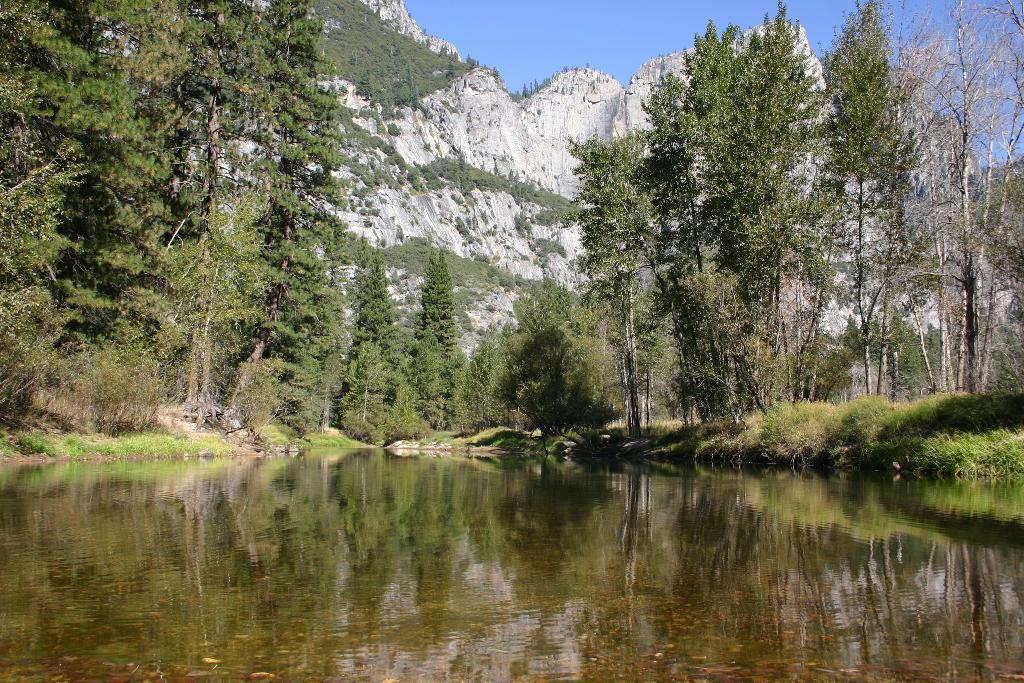What can be seen at the top of the image? The sky is visible towards the top of the image. What type of natural landforms are present in the image? There are mountains in the image. What type of vegetation can be seen in the image? There are trees and grass in the image. What is visible towards the bottom of the image? There is water visible towards the bottom of the image. What type of breakfast is being served on the vessel in the image? There is no vessel or breakfast present in the image; it features natural elements such as mountains, trees, grass, and water. What type of flower can be seen growing near the water in the image? There is no flower present in the image; it only features mountains, trees, grass, and water. 